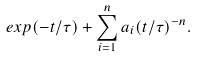Convert formula to latex. <formula><loc_0><loc_0><loc_500><loc_500>e x p ( - t / \tau ) + \sum _ { i = 1 } ^ { n } a _ { i } ( t / \tau ) ^ { - n } .</formula> 